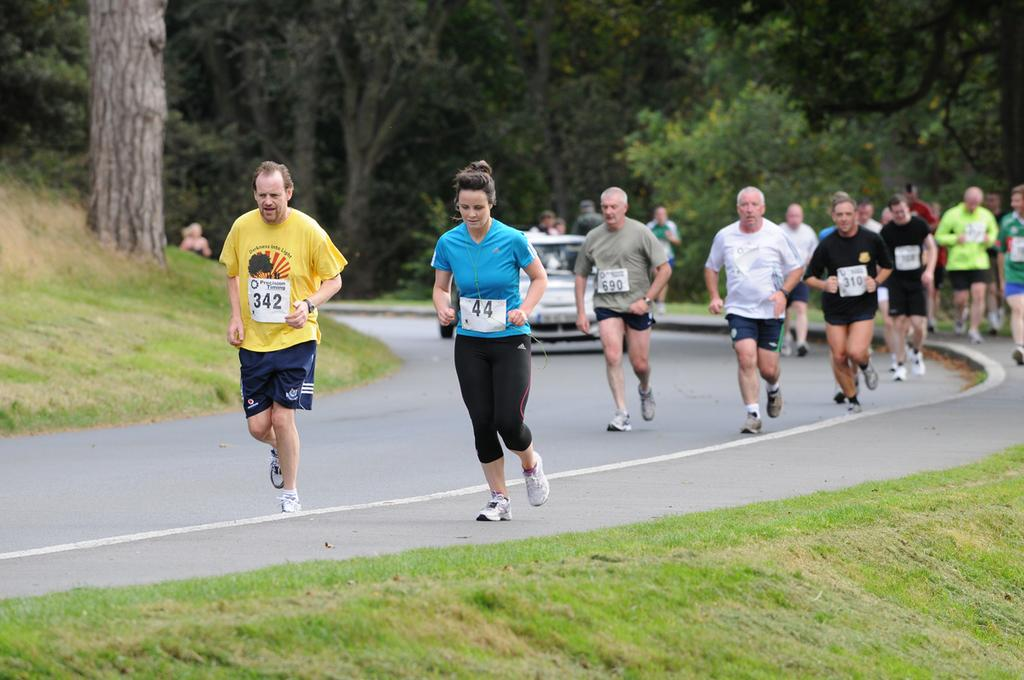How many people are in the group visible in the image? There is a group of people in the image, but the exact number cannot be determined without more specific information. What type of terrain is visible in the image? There is grass visible in the image, which suggests a grassy or park-like setting. What type of vehicle is present in the image? There is a vehicle in the image, but the specific type or model cannot be determined without more specific information. What type of vegetation is visible in the image? There are trees in the image, in addition to the grassy terrain. Can you see any insects sneezing in the image? There are no insects visible in the image, let alone any sneezing insects. How many breaths can be counted coming from the group of people in the image? It is not possible to count breaths from a group of people in a still image. 